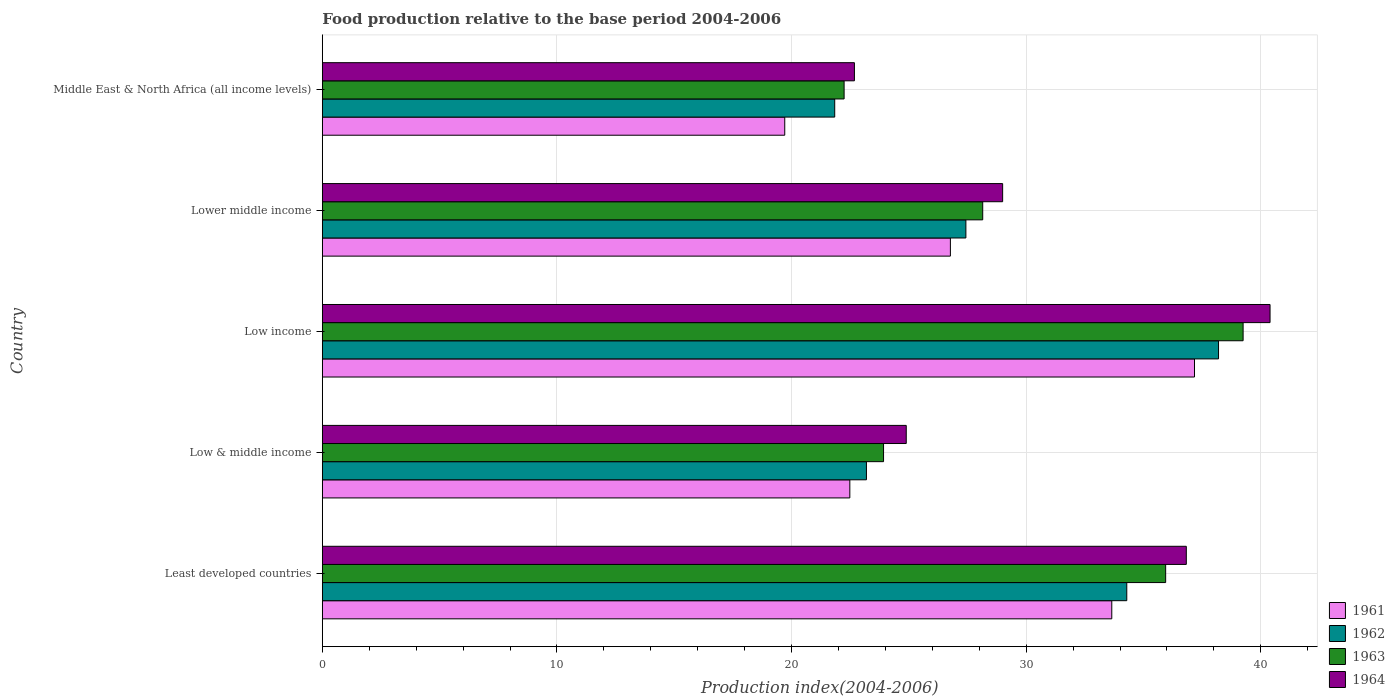Are the number of bars per tick equal to the number of legend labels?
Ensure brevity in your answer.  Yes. How many bars are there on the 4th tick from the top?
Your response must be concise. 4. What is the label of the 4th group of bars from the top?
Give a very brief answer. Low & middle income. What is the food production index in 1961 in Low income?
Provide a succinct answer. 37.17. Across all countries, what is the maximum food production index in 1962?
Provide a succinct answer. 38.2. Across all countries, what is the minimum food production index in 1961?
Your response must be concise. 19.71. In which country was the food production index in 1962 minimum?
Make the answer very short. Middle East & North Africa (all income levels). What is the total food production index in 1963 in the graph?
Offer a very short reply. 149.5. What is the difference between the food production index in 1961 in Low income and that in Lower middle income?
Your answer should be compact. 10.4. What is the difference between the food production index in 1961 in Middle East & North Africa (all income levels) and the food production index in 1962 in Low & middle income?
Give a very brief answer. -3.48. What is the average food production index in 1962 per country?
Offer a terse response. 28.99. What is the difference between the food production index in 1962 and food production index in 1963 in Low income?
Provide a short and direct response. -1.05. In how many countries, is the food production index in 1964 greater than 2 ?
Offer a terse response. 5. What is the ratio of the food production index in 1963 in Low & middle income to that in Low income?
Offer a very short reply. 0.61. Is the difference between the food production index in 1962 in Least developed countries and Lower middle income greater than the difference between the food production index in 1963 in Least developed countries and Lower middle income?
Make the answer very short. No. What is the difference between the highest and the second highest food production index in 1962?
Your answer should be very brief. 3.91. What is the difference between the highest and the lowest food production index in 1963?
Your response must be concise. 17.01. What does the 2nd bar from the bottom in Low & middle income represents?
Offer a terse response. 1962. Are all the bars in the graph horizontal?
Your response must be concise. Yes. Are the values on the major ticks of X-axis written in scientific E-notation?
Your answer should be compact. No. How many legend labels are there?
Keep it short and to the point. 4. How are the legend labels stacked?
Make the answer very short. Vertical. What is the title of the graph?
Make the answer very short. Food production relative to the base period 2004-2006. Does "1996" appear as one of the legend labels in the graph?
Keep it short and to the point. No. What is the label or title of the X-axis?
Provide a short and direct response. Production index(2004-2006). What is the Production index(2004-2006) of 1961 in Least developed countries?
Your answer should be very brief. 33.65. What is the Production index(2004-2006) of 1962 in Least developed countries?
Ensure brevity in your answer.  34.29. What is the Production index(2004-2006) in 1963 in Least developed countries?
Ensure brevity in your answer.  35.95. What is the Production index(2004-2006) in 1964 in Least developed countries?
Your response must be concise. 36.83. What is the Production index(2004-2006) in 1961 in Low & middle income?
Ensure brevity in your answer.  22.48. What is the Production index(2004-2006) in 1962 in Low & middle income?
Make the answer very short. 23.19. What is the Production index(2004-2006) of 1963 in Low & middle income?
Your response must be concise. 23.92. What is the Production index(2004-2006) of 1964 in Low & middle income?
Your response must be concise. 24.89. What is the Production index(2004-2006) of 1961 in Low income?
Provide a succinct answer. 37.17. What is the Production index(2004-2006) of 1962 in Low income?
Your response must be concise. 38.2. What is the Production index(2004-2006) of 1963 in Low income?
Keep it short and to the point. 39.25. What is the Production index(2004-2006) of 1964 in Low income?
Keep it short and to the point. 40.39. What is the Production index(2004-2006) of 1961 in Lower middle income?
Make the answer very short. 26.77. What is the Production index(2004-2006) of 1962 in Lower middle income?
Keep it short and to the point. 27.43. What is the Production index(2004-2006) in 1963 in Lower middle income?
Make the answer very short. 28.15. What is the Production index(2004-2006) of 1964 in Lower middle income?
Offer a terse response. 29. What is the Production index(2004-2006) in 1961 in Middle East & North Africa (all income levels)?
Provide a succinct answer. 19.71. What is the Production index(2004-2006) in 1962 in Middle East & North Africa (all income levels)?
Offer a terse response. 21.84. What is the Production index(2004-2006) in 1963 in Middle East & North Africa (all income levels)?
Your answer should be compact. 22.24. What is the Production index(2004-2006) of 1964 in Middle East & North Africa (all income levels)?
Your answer should be compact. 22.68. Across all countries, what is the maximum Production index(2004-2006) of 1961?
Offer a terse response. 37.17. Across all countries, what is the maximum Production index(2004-2006) of 1962?
Your answer should be very brief. 38.2. Across all countries, what is the maximum Production index(2004-2006) in 1963?
Provide a succinct answer. 39.25. Across all countries, what is the maximum Production index(2004-2006) of 1964?
Ensure brevity in your answer.  40.39. Across all countries, what is the minimum Production index(2004-2006) of 1961?
Provide a succinct answer. 19.71. Across all countries, what is the minimum Production index(2004-2006) of 1962?
Provide a succinct answer. 21.84. Across all countries, what is the minimum Production index(2004-2006) of 1963?
Offer a terse response. 22.24. Across all countries, what is the minimum Production index(2004-2006) of 1964?
Give a very brief answer. 22.68. What is the total Production index(2004-2006) of 1961 in the graph?
Keep it short and to the point. 139.79. What is the total Production index(2004-2006) of 1962 in the graph?
Your response must be concise. 144.95. What is the total Production index(2004-2006) of 1963 in the graph?
Provide a short and direct response. 149.5. What is the total Production index(2004-2006) of 1964 in the graph?
Offer a terse response. 153.78. What is the difference between the Production index(2004-2006) in 1961 in Least developed countries and that in Low & middle income?
Keep it short and to the point. 11.17. What is the difference between the Production index(2004-2006) in 1962 in Least developed countries and that in Low & middle income?
Provide a succinct answer. 11.1. What is the difference between the Production index(2004-2006) in 1963 in Least developed countries and that in Low & middle income?
Offer a terse response. 12.02. What is the difference between the Production index(2004-2006) in 1964 in Least developed countries and that in Low & middle income?
Offer a terse response. 11.94. What is the difference between the Production index(2004-2006) in 1961 in Least developed countries and that in Low income?
Provide a succinct answer. -3.53. What is the difference between the Production index(2004-2006) in 1962 in Least developed countries and that in Low income?
Give a very brief answer. -3.91. What is the difference between the Production index(2004-2006) in 1963 in Least developed countries and that in Low income?
Provide a succinct answer. -3.3. What is the difference between the Production index(2004-2006) in 1964 in Least developed countries and that in Low income?
Ensure brevity in your answer.  -3.57. What is the difference between the Production index(2004-2006) in 1961 in Least developed countries and that in Lower middle income?
Offer a very short reply. 6.88. What is the difference between the Production index(2004-2006) in 1962 in Least developed countries and that in Lower middle income?
Your response must be concise. 6.86. What is the difference between the Production index(2004-2006) in 1963 in Least developed countries and that in Lower middle income?
Make the answer very short. 7.8. What is the difference between the Production index(2004-2006) of 1964 in Least developed countries and that in Lower middle income?
Ensure brevity in your answer.  7.83. What is the difference between the Production index(2004-2006) in 1961 in Least developed countries and that in Middle East & North Africa (all income levels)?
Give a very brief answer. 13.94. What is the difference between the Production index(2004-2006) in 1962 in Least developed countries and that in Middle East & North Africa (all income levels)?
Ensure brevity in your answer.  12.45. What is the difference between the Production index(2004-2006) of 1963 in Least developed countries and that in Middle East & North Africa (all income levels)?
Offer a terse response. 13.71. What is the difference between the Production index(2004-2006) in 1964 in Least developed countries and that in Middle East & North Africa (all income levels)?
Provide a short and direct response. 14.15. What is the difference between the Production index(2004-2006) of 1961 in Low & middle income and that in Low income?
Ensure brevity in your answer.  -14.69. What is the difference between the Production index(2004-2006) in 1962 in Low & middle income and that in Low income?
Keep it short and to the point. -15.01. What is the difference between the Production index(2004-2006) of 1963 in Low & middle income and that in Low income?
Your response must be concise. -15.33. What is the difference between the Production index(2004-2006) of 1964 in Low & middle income and that in Low income?
Offer a terse response. -15.51. What is the difference between the Production index(2004-2006) of 1961 in Low & middle income and that in Lower middle income?
Offer a very short reply. -4.29. What is the difference between the Production index(2004-2006) in 1962 in Low & middle income and that in Lower middle income?
Ensure brevity in your answer.  -4.24. What is the difference between the Production index(2004-2006) in 1963 in Low & middle income and that in Lower middle income?
Ensure brevity in your answer.  -4.23. What is the difference between the Production index(2004-2006) in 1964 in Low & middle income and that in Lower middle income?
Ensure brevity in your answer.  -4.11. What is the difference between the Production index(2004-2006) in 1961 in Low & middle income and that in Middle East & North Africa (all income levels)?
Your response must be concise. 2.77. What is the difference between the Production index(2004-2006) in 1962 in Low & middle income and that in Middle East & North Africa (all income levels)?
Your answer should be compact. 1.35. What is the difference between the Production index(2004-2006) in 1963 in Low & middle income and that in Middle East & North Africa (all income levels)?
Keep it short and to the point. 1.68. What is the difference between the Production index(2004-2006) in 1964 in Low & middle income and that in Middle East & North Africa (all income levels)?
Your response must be concise. 2.21. What is the difference between the Production index(2004-2006) in 1961 in Low income and that in Lower middle income?
Provide a short and direct response. 10.4. What is the difference between the Production index(2004-2006) in 1962 in Low income and that in Lower middle income?
Offer a very short reply. 10.77. What is the difference between the Production index(2004-2006) in 1963 in Low income and that in Lower middle income?
Your response must be concise. 11.1. What is the difference between the Production index(2004-2006) in 1964 in Low income and that in Lower middle income?
Offer a terse response. 11.4. What is the difference between the Production index(2004-2006) in 1961 in Low income and that in Middle East & North Africa (all income levels)?
Provide a succinct answer. 17.46. What is the difference between the Production index(2004-2006) of 1962 in Low income and that in Middle East & North Africa (all income levels)?
Give a very brief answer. 16.36. What is the difference between the Production index(2004-2006) of 1963 in Low income and that in Middle East & North Africa (all income levels)?
Make the answer very short. 17.01. What is the difference between the Production index(2004-2006) of 1964 in Low income and that in Middle East & North Africa (all income levels)?
Offer a very short reply. 17.72. What is the difference between the Production index(2004-2006) in 1961 in Lower middle income and that in Middle East & North Africa (all income levels)?
Ensure brevity in your answer.  7.06. What is the difference between the Production index(2004-2006) of 1962 in Lower middle income and that in Middle East & North Africa (all income levels)?
Give a very brief answer. 5.59. What is the difference between the Production index(2004-2006) in 1963 in Lower middle income and that in Middle East & North Africa (all income levels)?
Your response must be concise. 5.91. What is the difference between the Production index(2004-2006) of 1964 in Lower middle income and that in Middle East & North Africa (all income levels)?
Ensure brevity in your answer.  6.32. What is the difference between the Production index(2004-2006) of 1961 in Least developed countries and the Production index(2004-2006) of 1962 in Low & middle income?
Provide a succinct answer. 10.46. What is the difference between the Production index(2004-2006) in 1961 in Least developed countries and the Production index(2004-2006) in 1963 in Low & middle income?
Provide a short and direct response. 9.73. What is the difference between the Production index(2004-2006) in 1961 in Least developed countries and the Production index(2004-2006) in 1964 in Low & middle income?
Provide a short and direct response. 8.76. What is the difference between the Production index(2004-2006) of 1962 in Least developed countries and the Production index(2004-2006) of 1963 in Low & middle income?
Provide a short and direct response. 10.37. What is the difference between the Production index(2004-2006) in 1962 in Least developed countries and the Production index(2004-2006) in 1964 in Low & middle income?
Your response must be concise. 9.4. What is the difference between the Production index(2004-2006) in 1963 in Least developed countries and the Production index(2004-2006) in 1964 in Low & middle income?
Your response must be concise. 11.06. What is the difference between the Production index(2004-2006) in 1961 in Least developed countries and the Production index(2004-2006) in 1962 in Low income?
Your response must be concise. -4.55. What is the difference between the Production index(2004-2006) in 1961 in Least developed countries and the Production index(2004-2006) in 1963 in Low income?
Offer a very short reply. -5.6. What is the difference between the Production index(2004-2006) in 1961 in Least developed countries and the Production index(2004-2006) in 1964 in Low income?
Provide a succinct answer. -6.75. What is the difference between the Production index(2004-2006) of 1962 in Least developed countries and the Production index(2004-2006) of 1963 in Low income?
Make the answer very short. -4.96. What is the difference between the Production index(2004-2006) of 1962 in Least developed countries and the Production index(2004-2006) of 1964 in Low income?
Give a very brief answer. -6.11. What is the difference between the Production index(2004-2006) of 1963 in Least developed countries and the Production index(2004-2006) of 1964 in Low income?
Keep it short and to the point. -4.45. What is the difference between the Production index(2004-2006) of 1961 in Least developed countries and the Production index(2004-2006) of 1962 in Lower middle income?
Provide a short and direct response. 6.22. What is the difference between the Production index(2004-2006) in 1961 in Least developed countries and the Production index(2004-2006) in 1963 in Lower middle income?
Keep it short and to the point. 5.5. What is the difference between the Production index(2004-2006) of 1961 in Least developed countries and the Production index(2004-2006) of 1964 in Lower middle income?
Provide a succinct answer. 4.65. What is the difference between the Production index(2004-2006) in 1962 in Least developed countries and the Production index(2004-2006) in 1963 in Lower middle income?
Give a very brief answer. 6.14. What is the difference between the Production index(2004-2006) of 1962 in Least developed countries and the Production index(2004-2006) of 1964 in Lower middle income?
Offer a very short reply. 5.29. What is the difference between the Production index(2004-2006) of 1963 in Least developed countries and the Production index(2004-2006) of 1964 in Lower middle income?
Your answer should be compact. 6.95. What is the difference between the Production index(2004-2006) of 1961 in Least developed countries and the Production index(2004-2006) of 1962 in Middle East & North Africa (all income levels)?
Keep it short and to the point. 11.81. What is the difference between the Production index(2004-2006) of 1961 in Least developed countries and the Production index(2004-2006) of 1963 in Middle East & North Africa (all income levels)?
Make the answer very short. 11.41. What is the difference between the Production index(2004-2006) in 1961 in Least developed countries and the Production index(2004-2006) in 1964 in Middle East & North Africa (all income levels)?
Your answer should be very brief. 10.97. What is the difference between the Production index(2004-2006) in 1962 in Least developed countries and the Production index(2004-2006) in 1963 in Middle East & North Africa (all income levels)?
Make the answer very short. 12.05. What is the difference between the Production index(2004-2006) in 1962 in Least developed countries and the Production index(2004-2006) in 1964 in Middle East & North Africa (all income levels)?
Provide a succinct answer. 11.61. What is the difference between the Production index(2004-2006) in 1963 in Least developed countries and the Production index(2004-2006) in 1964 in Middle East & North Africa (all income levels)?
Make the answer very short. 13.27. What is the difference between the Production index(2004-2006) in 1961 in Low & middle income and the Production index(2004-2006) in 1962 in Low income?
Give a very brief answer. -15.72. What is the difference between the Production index(2004-2006) in 1961 in Low & middle income and the Production index(2004-2006) in 1963 in Low income?
Your response must be concise. -16.76. What is the difference between the Production index(2004-2006) in 1961 in Low & middle income and the Production index(2004-2006) in 1964 in Low income?
Give a very brief answer. -17.91. What is the difference between the Production index(2004-2006) in 1962 in Low & middle income and the Production index(2004-2006) in 1963 in Low income?
Your answer should be very brief. -16.06. What is the difference between the Production index(2004-2006) in 1962 in Low & middle income and the Production index(2004-2006) in 1964 in Low income?
Offer a terse response. -17.2. What is the difference between the Production index(2004-2006) of 1963 in Low & middle income and the Production index(2004-2006) of 1964 in Low income?
Ensure brevity in your answer.  -16.47. What is the difference between the Production index(2004-2006) in 1961 in Low & middle income and the Production index(2004-2006) in 1962 in Lower middle income?
Provide a succinct answer. -4.95. What is the difference between the Production index(2004-2006) in 1961 in Low & middle income and the Production index(2004-2006) in 1963 in Lower middle income?
Your answer should be very brief. -5.66. What is the difference between the Production index(2004-2006) of 1961 in Low & middle income and the Production index(2004-2006) of 1964 in Lower middle income?
Your answer should be compact. -6.51. What is the difference between the Production index(2004-2006) of 1962 in Low & middle income and the Production index(2004-2006) of 1963 in Lower middle income?
Give a very brief answer. -4.96. What is the difference between the Production index(2004-2006) of 1962 in Low & middle income and the Production index(2004-2006) of 1964 in Lower middle income?
Ensure brevity in your answer.  -5.81. What is the difference between the Production index(2004-2006) of 1963 in Low & middle income and the Production index(2004-2006) of 1964 in Lower middle income?
Offer a terse response. -5.08. What is the difference between the Production index(2004-2006) of 1961 in Low & middle income and the Production index(2004-2006) of 1962 in Middle East & North Africa (all income levels)?
Offer a terse response. 0.64. What is the difference between the Production index(2004-2006) in 1961 in Low & middle income and the Production index(2004-2006) in 1963 in Middle East & North Africa (all income levels)?
Provide a short and direct response. 0.24. What is the difference between the Production index(2004-2006) in 1961 in Low & middle income and the Production index(2004-2006) in 1964 in Middle East & North Africa (all income levels)?
Offer a very short reply. -0.2. What is the difference between the Production index(2004-2006) in 1962 in Low & middle income and the Production index(2004-2006) in 1963 in Middle East & North Africa (all income levels)?
Provide a short and direct response. 0.95. What is the difference between the Production index(2004-2006) in 1962 in Low & middle income and the Production index(2004-2006) in 1964 in Middle East & North Africa (all income levels)?
Offer a very short reply. 0.51. What is the difference between the Production index(2004-2006) in 1963 in Low & middle income and the Production index(2004-2006) in 1964 in Middle East & North Africa (all income levels)?
Ensure brevity in your answer.  1.24. What is the difference between the Production index(2004-2006) in 1961 in Low income and the Production index(2004-2006) in 1962 in Lower middle income?
Offer a very short reply. 9.74. What is the difference between the Production index(2004-2006) of 1961 in Low income and the Production index(2004-2006) of 1963 in Lower middle income?
Your answer should be compact. 9.03. What is the difference between the Production index(2004-2006) in 1961 in Low income and the Production index(2004-2006) in 1964 in Lower middle income?
Offer a terse response. 8.18. What is the difference between the Production index(2004-2006) in 1962 in Low income and the Production index(2004-2006) in 1963 in Lower middle income?
Your answer should be compact. 10.05. What is the difference between the Production index(2004-2006) in 1962 in Low income and the Production index(2004-2006) in 1964 in Lower middle income?
Offer a very short reply. 9.2. What is the difference between the Production index(2004-2006) in 1963 in Low income and the Production index(2004-2006) in 1964 in Lower middle income?
Your response must be concise. 10.25. What is the difference between the Production index(2004-2006) of 1961 in Low income and the Production index(2004-2006) of 1962 in Middle East & North Africa (all income levels)?
Offer a very short reply. 15.33. What is the difference between the Production index(2004-2006) of 1961 in Low income and the Production index(2004-2006) of 1963 in Middle East & North Africa (all income levels)?
Make the answer very short. 14.93. What is the difference between the Production index(2004-2006) in 1961 in Low income and the Production index(2004-2006) in 1964 in Middle East & North Africa (all income levels)?
Ensure brevity in your answer.  14.5. What is the difference between the Production index(2004-2006) in 1962 in Low income and the Production index(2004-2006) in 1963 in Middle East & North Africa (all income levels)?
Give a very brief answer. 15.96. What is the difference between the Production index(2004-2006) of 1962 in Low income and the Production index(2004-2006) of 1964 in Middle East & North Africa (all income levels)?
Ensure brevity in your answer.  15.52. What is the difference between the Production index(2004-2006) of 1963 in Low income and the Production index(2004-2006) of 1964 in Middle East & North Africa (all income levels)?
Keep it short and to the point. 16.57. What is the difference between the Production index(2004-2006) of 1961 in Lower middle income and the Production index(2004-2006) of 1962 in Middle East & North Africa (all income levels)?
Keep it short and to the point. 4.93. What is the difference between the Production index(2004-2006) of 1961 in Lower middle income and the Production index(2004-2006) of 1963 in Middle East & North Africa (all income levels)?
Make the answer very short. 4.53. What is the difference between the Production index(2004-2006) of 1961 in Lower middle income and the Production index(2004-2006) of 1964 in Middle East & North Africa (all income levels)?
Provide a short and direct response. 4.09. What is the difference between the Production index(2004-2006) of 1962 in Lower middle income and the Production index(2004-2006) of 1963 in Middle East & North Africa (all income levels)?
Ensure brevity in your answer.  5.19. What is the difference between the Production index(2004-2006) of 1962 in Lower middle income and the Production index(2004-2006) of 1964 in Middle East & North Africa (all income levels)?
Give a very brief answer. 4.75. What is the difference between the Production index(2004-2006) in 1963 in Lower middle income and the Production index(2004-2006) in 1964 in Middle East & North Africa (all income levels)?
Offer a very short reply. 5.47. What is the average Production index(2004-2006) in 1961 per country?
Provide a succinct answer. 27.96. What is the average Production index(2004-2006) in 1962 per country?
Ensure brevity in your answer.  28.99. What is the average Production index(2004-2006) in 1963 per country?
Provide a short and direct response. 29.9. What is the average Production index(2004-2006) of 1964 per country?
Ensure brevity in your answer.  30.76. What is the difference between the Production index(2004-2006) of 1961 and Production index(2004-2006) of 1962 in Least developed countries?
Provide a short and direct response. -0.64. What is the difference between the Production index(2004-2006) in 1961 and Production index(2004-2006) in 1963 in Least developed countries?
Offer a very short reply. -2.3. What is the difference between the Production index(2004-2006) of 1961 and Production index(2004-2006) of 1964 in Least developed countries?
Ensure brevity in your answer.  -3.18. What is the difference between the Production index(2004-2006) in 1962 and Production index(2004-2006) in 1963 in Least developed countries?
Provide a succinct answer. -1.66. What is the difference between the Production index(2004-2006) of 1962 and Production index(2004-2006) of 1964 in Least developed countries?
Your response must be concise. -2.54. What is the difference between the Production index(2004-2006) of 1963 and Production index(2004-2006) of 1964 in Least developed countries?
Offer a terse response. -0.88. What is the difference between the Production index(2004-2006) of 1961 and Production index(2004-2006) of 1962 in Low & middle income?
Provide a short and direct response. -0.71. What is the difference between the Production index(2004-2006) of 1961 and Production index(2004-2006) of 1963 in Low & middle income?
Offer a terse response. -1.44. What is the difference between the Production index(2004-2006) in 1961 and Production index(2004-2006) in 1964 in Low & middle income?
Make the answer very short. -2.4. What is the difference between the Production index(2004-2006) in 1962 and Production index(2004-2006) in 1963 in Low & middle income?
Provide a short and direct response. -0.73. What is the difference between the Production index(2004-2006) in 1962 and Production index(2004-2006) in 1964 in Low & middle income?
Your answer should be very brief. -1.7. What is the difference between the Production index(2004-2006) in 1963 and Production index(2004-2006) in 1964 in Low & middle income?
Keep it short and to the point. -0.97. What is the difference between the Production index(2004-2006) in 1961 and Production index(2004-2006) in 1962 in Low income?
Your answer should be very brief. -1.02. What is the difference between the Production index(2004-2006) in 1961 and Production index(2004-2006) in 1963 in Low income?
Your answer should be compact. -2.07. What is the difference between the Production index(2004-2006) in 1961 and Production index(2004-2006) in 1964 in Low income?
Provide a short and direct response. -3.22. What is the difference between the Production index(2004-2006) of 1962 and Production index(2004-2006) of 1963 in Low income?
Ensure brevity in your answer.  -1.05. What is the difference between the Production index(2004-2006) in 1962 and Production index(2004-2006) in 1964 in Low income?
Offer a very short reply. -2.2. What is the difference between the Production index(2004-2006) of 1963 and Production index(2004-2006) of 1964 in Low income?
Give a very brief answer. -1.15. What is the difference between the Production index(2004-2006) of 1961 and Production index(2004-2006) of 1962 in Lower middle income?
Your answer should be very brief. -0.66. What is the difference between the Production index(2004-2006) of 1961 and Production index(2004-2006) of 1963 in Lower middle income?
Offer a very short reply. -1.38. What is the difference between the Production index(2004-2006) of 1961 and Production index(2004-2006) of 1964 in Lower middle income?
Ensure brevity in your answer.  -2.23. What is the difference between the Production index(2004-2006) of 1962 and Production index(2004-2006) of 1963 in Lower middle income?
Give a very brief answer. -0.72. What is the difference between the Production index(2004-2006) of 1962 and Production index(2004-2006) of 1964 in Lower middle income?
Provide a succinct answer. -1.57. What is the difference between the Production index(2004-2006) in 1963 and Production index(2004-2006) in 1964 in Lower middle income?
Your answer should be very brief. -0.85. What is the difference between the Production index(2004-2006) in 1961 and Production index(2004-2006) in 1962 in Middle East & North Africa (all income levels)?
Provide a short and direct response. -2.13. What is the difference between the Production index(2004-2006) in 1961 and Production index(2004-2006) in 1963 in Middle East & North Africa (all income levels)?
Keep it short and to the point. -2.53. What is the difference between the Production index(2004-2006) in 1961 and Production index(2004-2006) in 1964 in Middle East & North Africa (all income levels)?
Your response must be concise. -2.97. What is the difference between the Production index(2004-2006) of 1962 and Production index(2004-2006) of 1963 in Middle East & North Africa (all income levels)?
Your answer should be very brief. -0.4. What is the difference between the Production index(2004-2006) of 1962 and Production index(2004-2006) of 1964 in Middle East & North Africa (all income levels)?
Ensure brevity in your answer.  -0.84. What is the difference between the Production index(2004-2006) of 1963 and Production index(2004-2006) of 1964 in Middle East & North Africa (all income levels)?
Keep it short and to the point. -0.44. What is the ratio of the Production index(2004-2006) of 1961 in Least developed countries to that in Low & middle income?
Offer a terse response. 1.5. What is the ratio of the Production index(2004-2006) in 1962 in Least developed countries to that in Low & middle income?
Make the answer very short. 1.48. What is the ratio of the Production index(2004-2006) in 1963 in Least developed countries to that in Low & middle income?
Make the answer very short. 1.5. What is the ratio of the Production index(2004-2006) in 1964 in Least developed countries to that in Low & middle income?
Provide a succinct answer. 1.48. What is the ratio of the Production index(2004-2006) of 1961 in Least developed countries to that in Low income?
Provide a succinct answer. 0.91. What is the ratio of the Production index(2004-2006) in 1962 in Least developed countries to that in Low income?
Keep it short and to the point. 0.9. What is the ratio of the Production index(2004-2006) in 1963 in Least developed countries to that in Low income?
Give a very brief answer. 0.92. What is the ratio of the Production index(2004-2006) of 1964 in Least developed countries to that in Low income?
Provide a succinct answer. 0.91. What is the ratio of the Production index(2004-2006) of 1961 in Least developed countries to that in Lower middle income?
Make the answer very short. 1.26. What is the ratio of the Production index(2004-2006) in 1962 in Least developed countries to that in Lower middle income?
Provide a short and direct response. 1.25. What is the ratio of the Production index(2004-2006) of 1963 in Least developed countries to that in Lower middle income?
Keep it short and to the point. 1.28. What is the ratio of the Production index(2004-2006) of 1964 in Least developed countries to that in Lower middle income?
Offer a terse response. 1.27. What is the ratio of the Production index(2004-2006) in 1961 in Least developed countries to that in Middle East & North Africa (all income levels)?
Give a very brief answer. 1.71. What is the ratio of the Production index(2004-2006) of 1962 in Least developed countries to that in Middle East & North Africa (all income levels)?
Ensure brevity in your answer.  1.57. What is the ratio of the Production index(2004-2006) of 1963 in Least developed countries to that in Middle East & North Africa (all income levels)?
Give a very brief answer. 1.62. What is the ratio of the Production index(2004-2006) in 1964 in Least developed countries to that in Middle East & North Africa (all income levels)?
Your answer should be compact. 1.62. What is the ratio of the Production index(2004-2006) of 1961 in Low & middle income to that in Low income?
Offer a terse response. 0.6. What is the ratio of the Production index(2004-2006) of 1962 in Low & middle income to that in Low income?
Your answer should be very brief. 0.61. What is the ratio of the Production index(2004-2006) of 1963 in Low & middle income to that in Low income?
Provide a short and direct response. 0.61. What is the ratio of the Production index(2004-2006) of 1964 in Low & middle income to that in Low income?
Ensure brevity in your answer.  0.62. What is the ratio of the Production index(2004-2006) of 1961 in Low & middle income to that in Lower middle income?
Ensure brevity in your answer.  0.84. What is the ratio of the Production index(2004-2006) of 1962 in Low & middle income to that in Lower middle income?
Provide a succinct answer. 0.85. What is the ratio of the Production index(2004-2006) of 1963 in Low & middle income to that in Lower middle income?
Give a very brief answer. 0.85. What is the ratio of the Production index(2004-2006) in 1964 in Low & middle income to that in Lower middle income?
Ensure brevity in your answer.  0.86. What is the ratio of the Production index(2004-2006) of 1961 in Low & middle income to that in Middle East & North Africa (all income levels)?
Your answer should be very brief. 1.14. What is the ratio of the Production index(2004-2006) of 1962 in Low & middle income to that in Middle East & North Africa (all income levels)?
Keep it short and to the point. 1.06. What is the ratio of the Production index(2004-2006) in 1963 in Low & middle income to that in Middle East & North Africa (all income levels)?
Give a very brief answer. 1.08. What is the ratio of the Production index(2004-2006) of 1964 in Low & middle income to that in Middle East & North Africa (all income levels)?
Your response must be concise. 1.1. What is the ratio of the Production index(2004-2006) in 1961 in Low income to that in Lower middle income?
Make the answer very short. 1.39. What is the ratio of the Production index(2004-2006) of 1962 in Low income to that in Lower middle income?
Your response must be concise. 1.39. What is the ratio of the Production index(2004-2006) in 1963 in Low income to that in Lower middle income?
Provide a succinct answer. 1.39. What is the ratio of the Production index(2004-2006) of 1964 in Low income to that in Lower middle income?
Offer a terse response. 1.39. What is the ratio of the Production index(2004-2006) in 1961 in Low income to that in Middle East & North Africa (all income levels)?
Ensure brevity in your answer.  1.89. What is the ratio of the Production index(2004-2006) in 1962 in Low income to that in Middle East & North Africa (all income levels)?
Ensure brevity in your answer.  1.75. What is the ratio of the Production index(2004-2006) in 1963 in Low income to that in Middle East & North Africa (all income levels)?
Provide a succinct answer. 1.76. What is the ratio of the Production index(2004-2006) in 1964 in Low income to that in Middle East & North Africa (all income levels)?
Offer a very short reply. 1.78. What is the ratio of the Production index(2004-2006) of 1961 in Lower middle income to that in Middle East & North Africa (all income levels)?
Keep it short and to the point. 1.36. What is the ratio of the Production index(2004-2006) in 1962 in Lower middle income to that in Middle East & North Africa (all income levels)?
Your response must be concise. 1.26. What is the ratio of the Production index(2004-2006) in 1963 in Lower middle income to that in Middle East & North Africa (all income levels)?
Provide a short and direct response. 1.27. What is the ratio of the Production index(2004-2006) in 1964 in Lower middle income to that in Middle East & North Africa (all income levels)?
Your answer should be compact. 1.28. What is the difference between the highest and the second highest Production index(2004-2006) of 1961?
Make the answer very short. 3.53. What is the difference between the highest and the second highest Production index(2004-2006) in 1962?
Offer a very short reply. 3.91. What is the difference between the highest and the second highest Production index(2004-2006) of 1963?
Keep it short and to the point. 3.3. What is the difference between the highest and the second highest Production index(2004-2006) in 1964?
Offer a terse response. 3.57. What is the difference between the highest and the lowest Production index(2004-2006) in 1961?
Make the answer very short. 17.46. What is the difference between the highest and the lowest Production index(2004-2006) of 1962?
Ensure brevity in your answer.  16.36. What is the difference between the highest and the lowest Production index(2004-2006) of 1963?
Make the answer very short. 17.01. What is the difference between the highest and the lowest Production index(2004-2006) in 1964?
Provide a succinct answer. 17.72. 